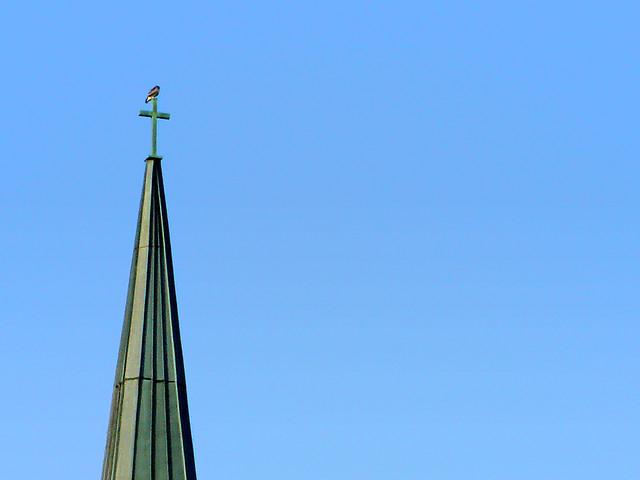Is the sky clear?
Give a very brief answer. Yes. What is on top of the cross?
Answer briefly. Bird. Is this a working clock?
Give a very brief answer. No. Is this the steeple of a church?
Write a very short answer. Yes. Overcast or sunny?
Write a very short answer. Sunny. Is this a tower clock?
Give a very brief answer. No. Is it raining?
Concise answer only. No. 